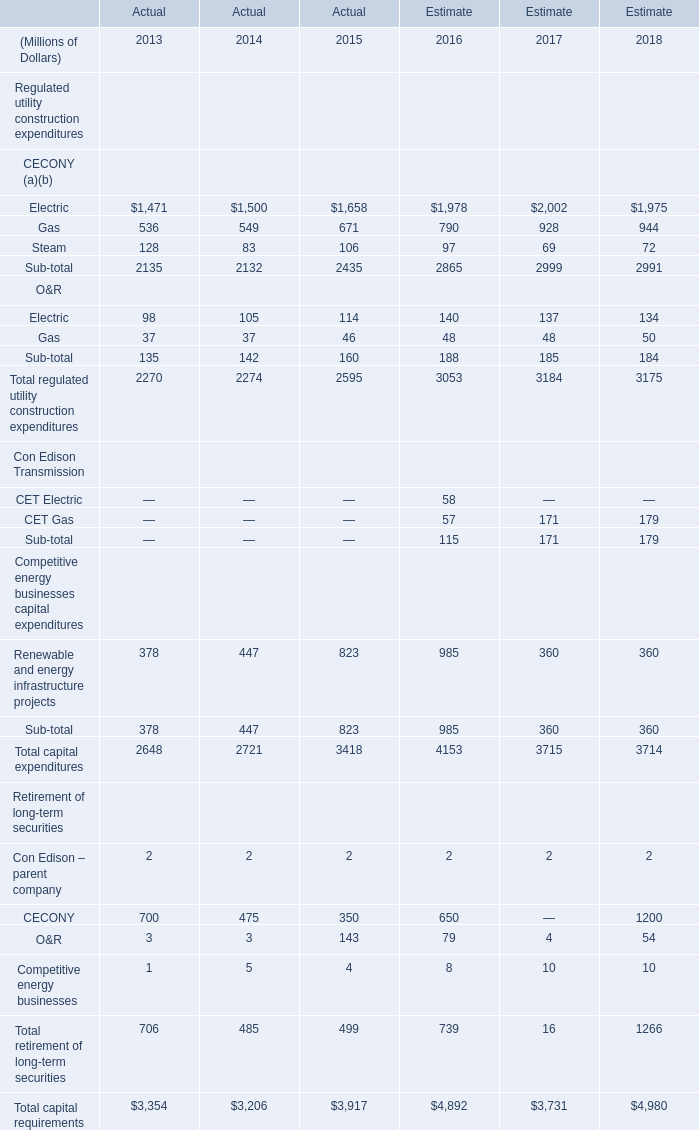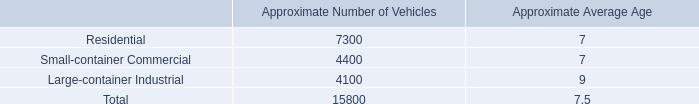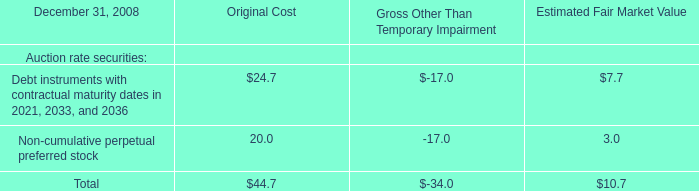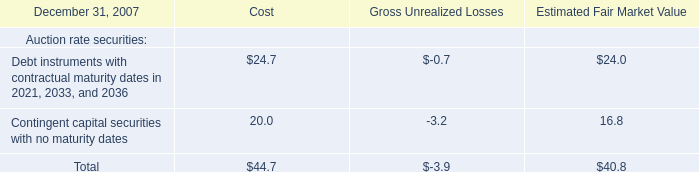What was the total amount of Gas in the range of 1 and 600 in 2013? (in million) 
Computations: (536 + 37)
Answer: 573.0. 